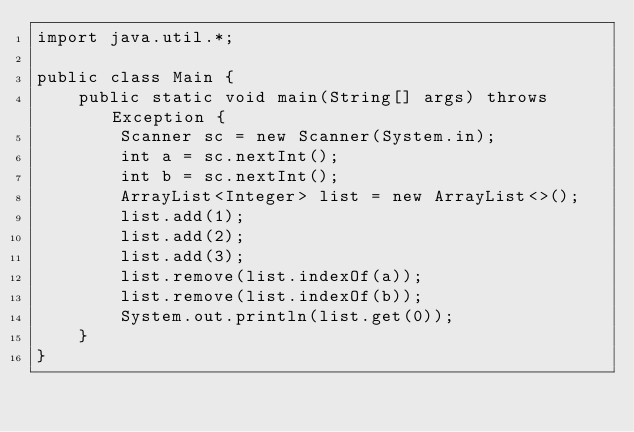Convert code to text. <code><loc_0><loc_0><loc_500><loc_500><_Java_>import java.util.*;

public class Main {
    public static void main(String[] args) throws Exception {
        Scanner sc = new Scanner(System.in);
        int a = sc.nextInt();
        int b = sc.nextInt();
        ArrayList<Integer> list = new ArrayList<>();
        list.add(1);
        list.add(2);
        list.add(3);
        list.remove(list.indexOf(a));
        list.remove(list.indexOf(b));
        System.out.println(list.get(0));
    }
}
</code> 